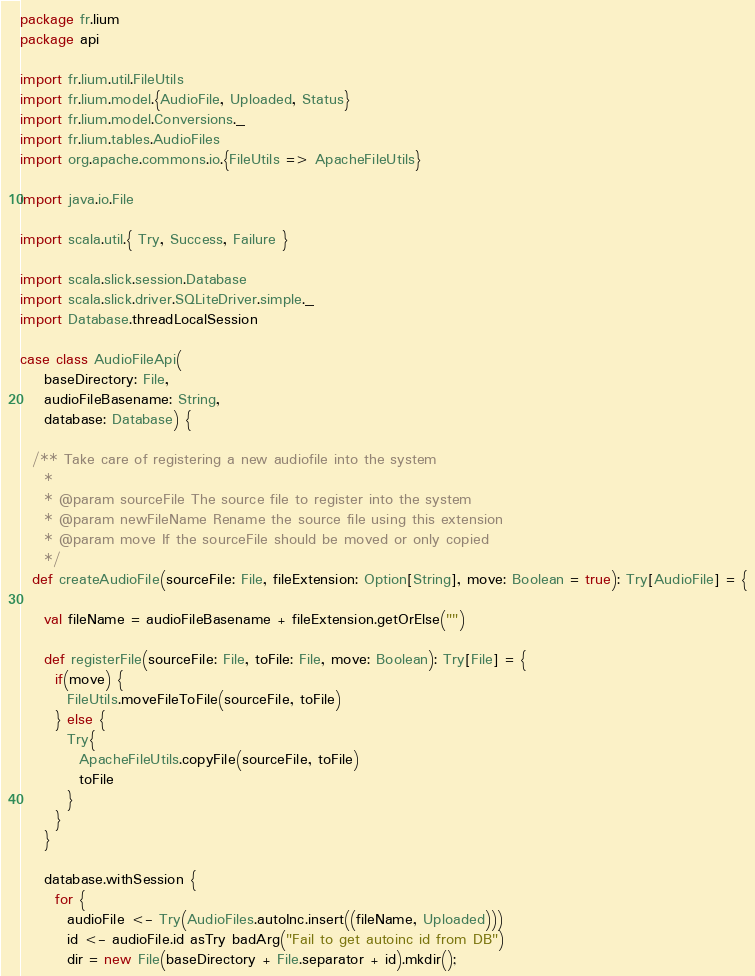<code> <loc_0><loc_0><loc_500><loc_500><_Scala_>package fr.lium
package api

import fr.lium.util.FileUtils
import fr.lium.model.{AudioFile, Uploaded, Status}
import fr.lium.model.Conversions._
import fr.lium.tables.AudioFiles
import org.apache.commons.io.{FileUtils => ApacheFileUtils}

import java.io.File

import scala.util.{ Try, Success, Failure }

import scala.slick.session.Database
import scala.slick.driver.SQLiteDriver.simple._
import Database.threadLocalSession

case class AudioFileApi(
    baseDirectory: File,
    audioFileBasename: String,
    database: Database) {

  /** Take care of registering a new audiofile into the system
    *
    * @param sourceFile The source file to register into the system
    * @param newFileName Rename the source file using this extension
    * @param move If the sourceFile should be moved or only copied
    */
  def createAudioFile(sourceFile: File, fileExtension: Option[String], move: Boolean = true): Try[AudioFile] = {

    val fileName = audioFileBasename + fileExtension.getOrElse("")

    def registerFile(sourceFile: File, toFile: File, move: Boolean): Try[File] = {
      if(move) {
        FileUtils.moveFileToFile(sourceFile, toFile)
      } else {
        Try{
          ApacheFileUtils.copyFile(sourceFile, toFile)
          toFile
        }
      }
    }

    database.withSession {
      for {
        audioFile <- Try(AudioFiles.autoInc.insert((fileName, Uploaded)))
        id <- audioFile.id asTry badArg("Fail to get autoinc id from DB")
        dir = new File(baseDirectory + File.separator + id).mkdir();</code> 